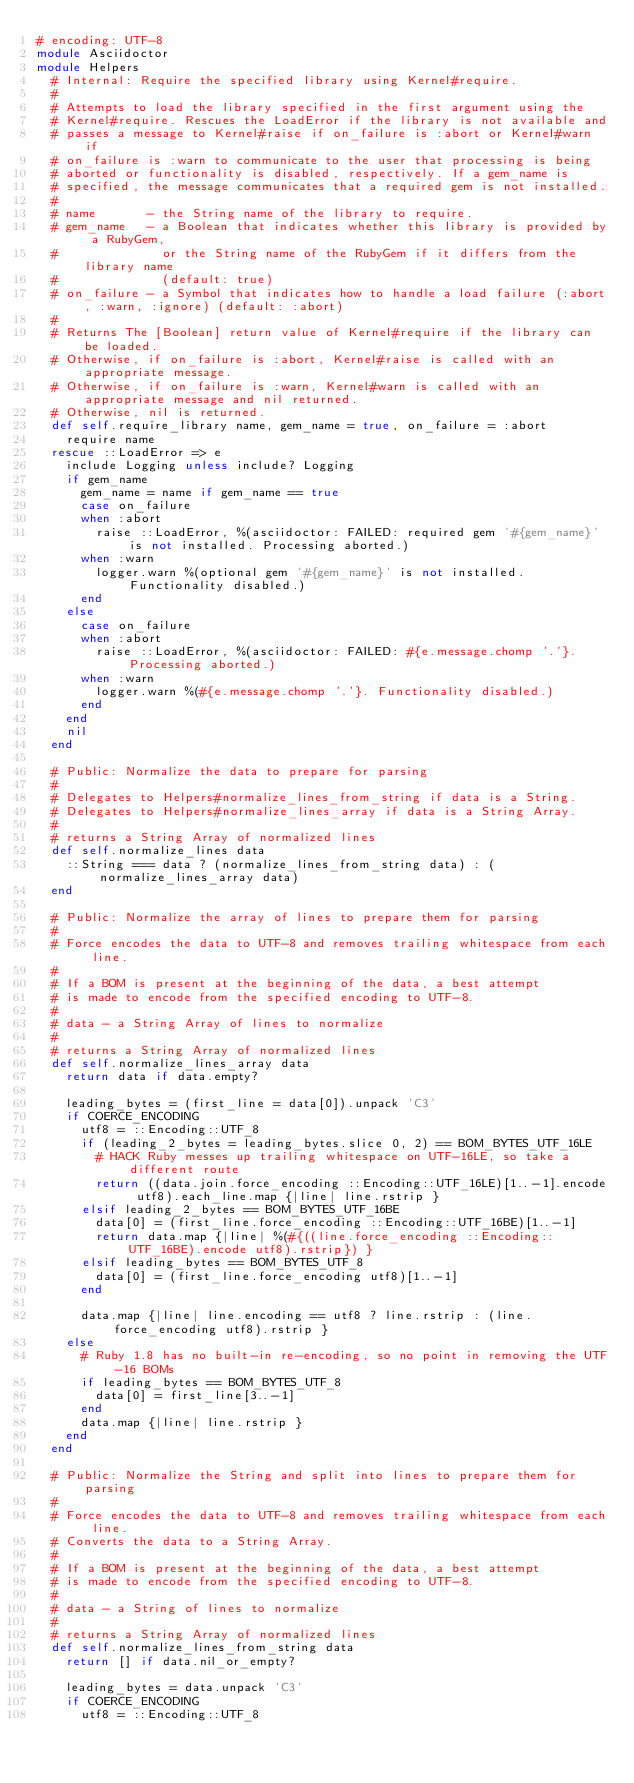Convert code to text. <code><loc_0><loc_0><loc_500><loc_500><_Ruby_># encoding: UTF-8
module Asciidoctor
module Helpers
  # Internal: Require the specified library using Kernel#require.
  #
  # Attempts to load the library specified in the first argument using the
  # Kernel#require. Rescues the LoadError if the library is not available and
  # passes a message to Kernel#raise if on_failure is :abort or Kernel#warn if
  # on_failure is :warn to communicate to the user that processing is being
  # aborted or functionality is disabled, respectively. If a gem_name is
  # specified, the message communicates that a required gem is not installed.
  #
  # name       - the String name of the library to require.
  # gem_name   - a Boolean that indicates whether this library is provided by a RubyGem,
  #              or the String name of the RubyGem if it differs from the library name
  #              (default: true)
  # on_failure - a Symbol that indicates how to handle a load failure (:abort, :warn, :ignore) (default: :abort)
  #
  # Returns The [Boolean] return value of Kernel#require if the library can be loaded.
  # Otherwise, if on_failure is :abort, Kernel#raise is called with an appropriate message.
  # Otherwise, if on_failure is :warn, Kernel#warn is called with an appropriate message and nil returned.
  # Otherwise, nil is returned.
  def self.require_library name, gem_name = true, on_failure = :abort
    require name
  rescue ::LoadError => e
    include Logging unless include? Logging
    if gem_name
      gem_name = name if gem_name == true
      case on_failure
      when :abort
        raise ::LoadError, %(asciidoctor: FAILED: required gem '#{gem_name}' is not installed. Processing aborted.)
      when :warn
        logger.warn %(optional gem '#{gem_name}' is not installed. Functionality disabled.)
      end
    else
      case on_failure
      when :abort
        raise ::LoadError, %(asciidoctor: FAILED: #{e.message.chomp '.'}. Processing aborted.)
      when :warn
        logger.warn %(#{e.message.chomp '.'}. Functionality disabled.)
      end
    end
    nil
  end

  # Public: Normalize the data to prepare for parsing
  #
  # Delegates to Helpers#normalize_lines_from_string if data is a String.
  # Delegates to Helpers#normalize_lines_array if data is a String Array.
  #
  # returns a String Array of normalized lines
  def self.normalize_lines data
    ::String === data ? (normalize_lines_from_string data) : (normalize_lines_array data)
  end

  # Public: Normalize the array of lines to prepare them for parsing
  #
  # Force encodes the data to UTF-8 and removes trailing whitespace from each line.
  #
  # If a BOM is present at the beginning of the data, a best attempt
  # is made to encode from the specified encoding to UTF-8.
  #
  # data - a String Array of lines to normalize
  #
  # returns a String Array of normalized lines
  def self.normalize_lines_array data
    return data if data.empty?

    leading_bytes = (first_line = data[0]).unpack 'C3'
    if COERCE_ENCODING
      utf8 = ::Encoding::UTF_8
      if (leading_2_bytes = leading_bytes.slice 0, 2) == BOM_BYTES_UTF_16LE
        # HACK Ruby messes up trailing whitespace on UTF-16LE, so take a different route
        return ((data.join.force_encoding ::Encoding::UTF_16LE)[1..-1].encode utf8).each_line.map {|line| line.rstrip }
      elsif leading_2_bytes == BOM_BYTES_UTF_16BE
        data[0] = (first_line.force_encoding ::Encoding::UTF_16BE)[1..-1]
        return data.map {|line| %(#{((line.force_encoding ::Encoding::UTF_16BE).encode utf8).rstrip}) }
      elsif leading_bytes == BOM_BYTES_UTF_8
        data[0] = (first_line.force_encoding utf8)[1..-1]
      end

      data.map {|line| line.encoding == utf8 ? line.rstrip : (line.force_encoding utf8).rstrip }
    else
      # Ruby 1.8 has no built-in re-encoding, so no point in removing the UTF-16 BOMs
      if leading_bytes == BOM_BYTES_UTF_8
        data[0] = first_line[3..-1]
      end
      data.map {|line| line.rstrip }
    end
  end

  # Public: Normalize the String and split into lines to prepare them for parsing
  #
  # Force encodes the data to UTF-8 and removes trailing whitespace from each line.
  # Converts the data to a String Array.
  #
  # If a BOM is present at the beginning of the data, a best attempt
  # is made to encode from the specified encoding to UTF-8.
  #
  # data - a String of lines to normalize
  #
  # returns a String Array of normalized lines
  def self.normalize_lines_from_string data
    return [] if data.nil_or_empty?

    leading_bytes = data.unpack 'C3'
    if COERCE_ENCODING
      utf8 = ::Encoding::UTF_8</code> 